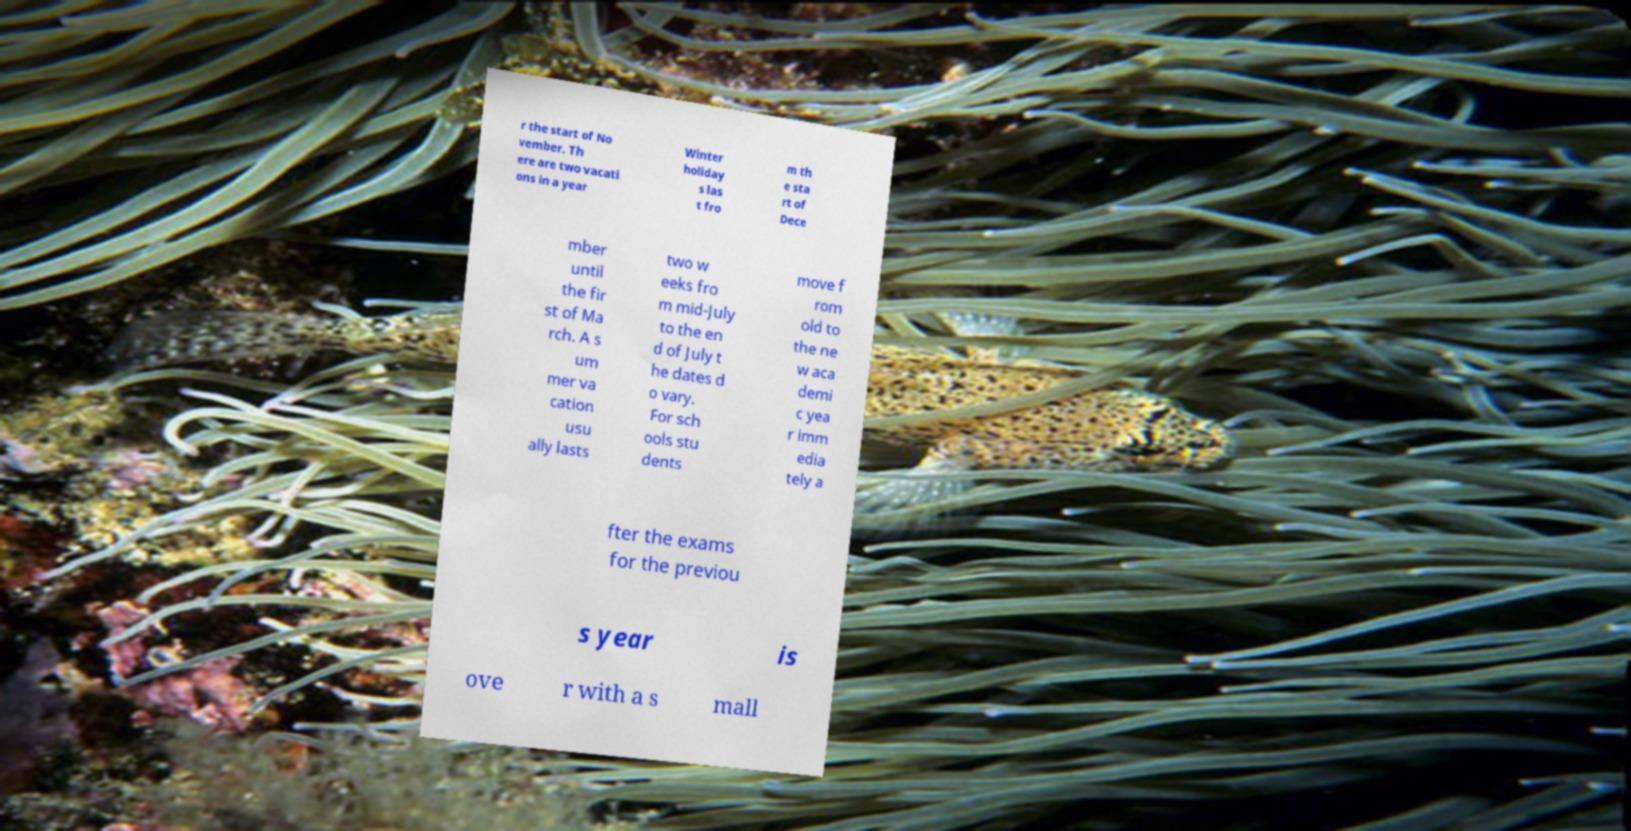Could you extract and type out the text from this image? r the start of No vember. Th ere are two vacati ons in a year Winter holiday s las t fro m th e sta rt of Dece mber until the fir st of Ma rch. A s um mer va cation usu ally lasts two w eeks fro m mid-July to the en d of July t he dates d o vary. For sch ools stu dents move f rom old to the ne w aca demi c yea r imm edia tely a fter the exams for the previou s year is ove r with a s mall 